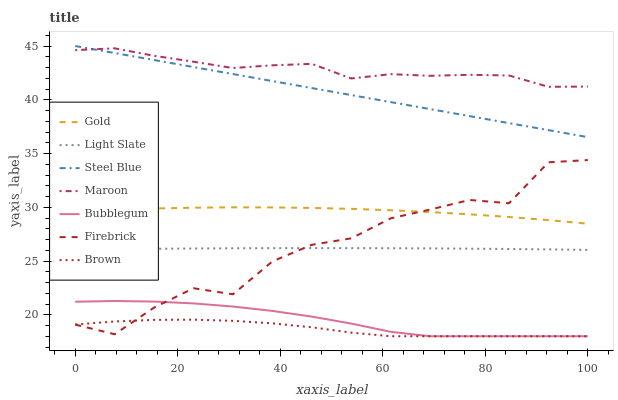Does Brown have the minimum area under the curve?
Answer yes or no. Yes. Does Maroon have the maximum area under the curve?
Answer yes or no. Yes. Does Gold have the minimum area under the curve?
Answer yes or no. No. Does Gold have the maximum area under the curve?
Answer yes or no. No. Is Steel Blue the smoothest?
Answer yes or no. Yes. Is Firebrick the roughest?
Answer yes or no. Yes. Is Gold the smoothest?
Answer yes or no. No. Is Gold the roughest?
Answer yes or no. No. Does Gold have the lowest value?
Answer yes or no. No. Does Gold have the highest value?
Answer yes or no. No. Is Bubblegum less than Steel Blue?
Answer yes or no. Yes. Is Steel Blue greater than Firebrick?
Answer yes or no. Yes. Does Bubblegum intersect Steel Blue?
Answer yes or no. No. 